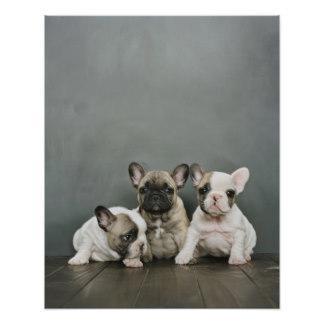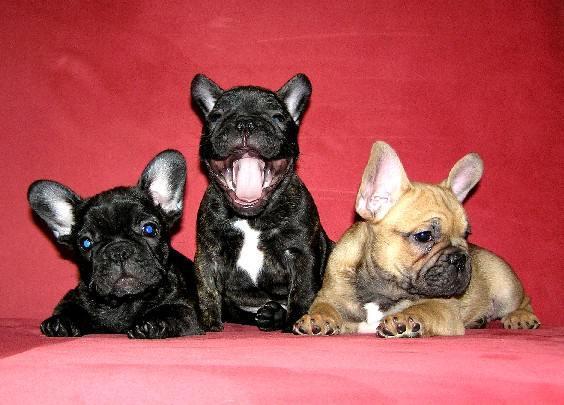The first image is the image on the left, the second image is the image on the right. For the images displayed, is the sentence "One of the images features a dog chewing an object." factually correct? Answer yes or no. No. The first image is the image on the left, the second image is the image on the right. Given the left and right images, does the statement "Each image features one bulldog posed with something in front of its face, and the dog on the left is gnawing on something." hold true? Answer yes or no. No. 